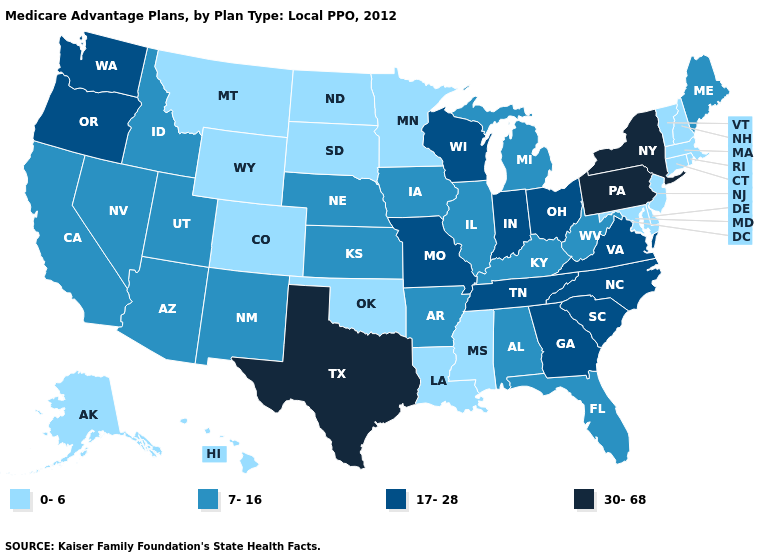Does Minnesota have a lower value than Alaska?
Short answer required. No. Does Pennsylvania have the lowest value in the Northeast?
Write a very short answer. No. Name the states that have a value in the range 0-6?
Keep it brief. Alaska, Colorado, Connecticut, Delaware, Hawaii, Louisiana, Massachusetts, Maryland, Minnesota, Mississippi, Montana, North Dakota, New Hampshire, New Jersey, Oklahoma, Rhode Island, South Dakota, Vermont, Wyoming. Among the states that border Alabama , which have the highest value?
Concise answer only. Georgia, Tennessee. What is the value of New Jersey?
Give a very brief answer. 0-6. What is the value of Hawaii?
Give a very brief answer. 0-6. Which states have the highest value in the USA?
Answer briefly. New York, Pennsylvania, Texas. What is the value of Colorado?
Answer briefly. 0-6. What is the lowest value in the USA?
Quick response, please. 0-6. What is the value of Montana?
Quick response, please. 0-6. Name the states that have a value in the range 0-6?
Quick response, please. Alaska, Colorado, Connecticut, Delaware, Hawaii, Louisiana, Massachusetts, Maryland, Minnesota, Mississippi, Montana, North Dakota, New Hampshire, New Jersey, Oklahoma, Rhode Island, South Dakota, Vermont, Wyoming. Does Minnesota have a lower value than Maryland?
Short answer required. No. Does the first symbol in the legend represent the smallest category?
Be succinct. Yes. What is the highest value in the Northeast ?
Answer briefly. 30-68. 